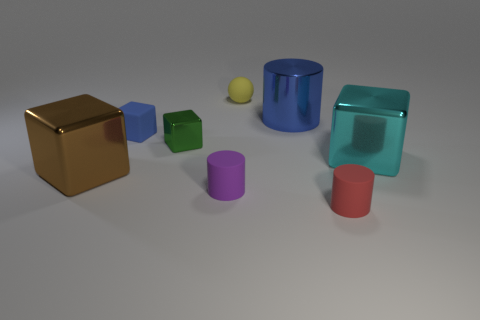Subtract all big cyan shiny cubes. How many cubes are left? 3 Subtract all brown blocks. How many blocks are left? 3 Add 1 big blue objects. How many objects exist? 9 Subtract all brown cylinders. Subtract all gray spheres. How many cylinders are left? 3 Subtract all cylinders. How many objects are left? 5 Subtract 0 green cylinders. How many objects are left? 8 Subtract all tiny green shiny blocks. Subtract all big brown metallic things. How many objects are left? 6 Add 8 big blue metal cylinders. How many big blue metal cylinders are left? 9 Add 1 small shiny things. How many small shiny things exist? 2 